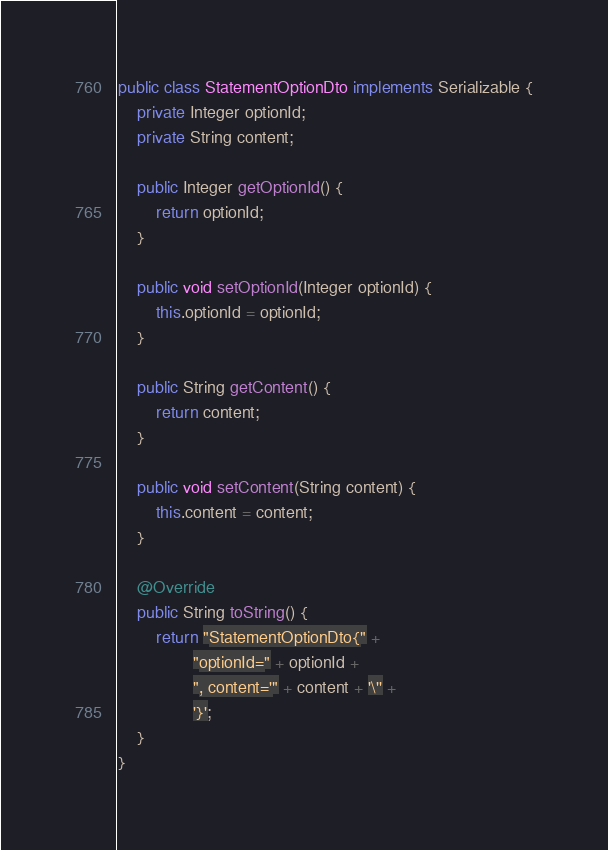<code> <loc_0><loc_0><loc_500><loc_500><_Java_>public class StatementOptionDto implements Serializable {
    private Integer optionId;
    private String content;

    public Integer getOptionId() {
        return optionId;
    }

    public void setOptionId(Integer optionId) {
        this.optionId = optionId;
    }

    public String getContent() {
        return content;
    }

    public void setContent(String content) {
        this.content = content;
    }

    @Override
    public String toString() {
        return "StatementOptionDto{" +
                "optionId=" + optionId +
                ", content='" + content + '\'' +
                '}';
    }
}</code> 